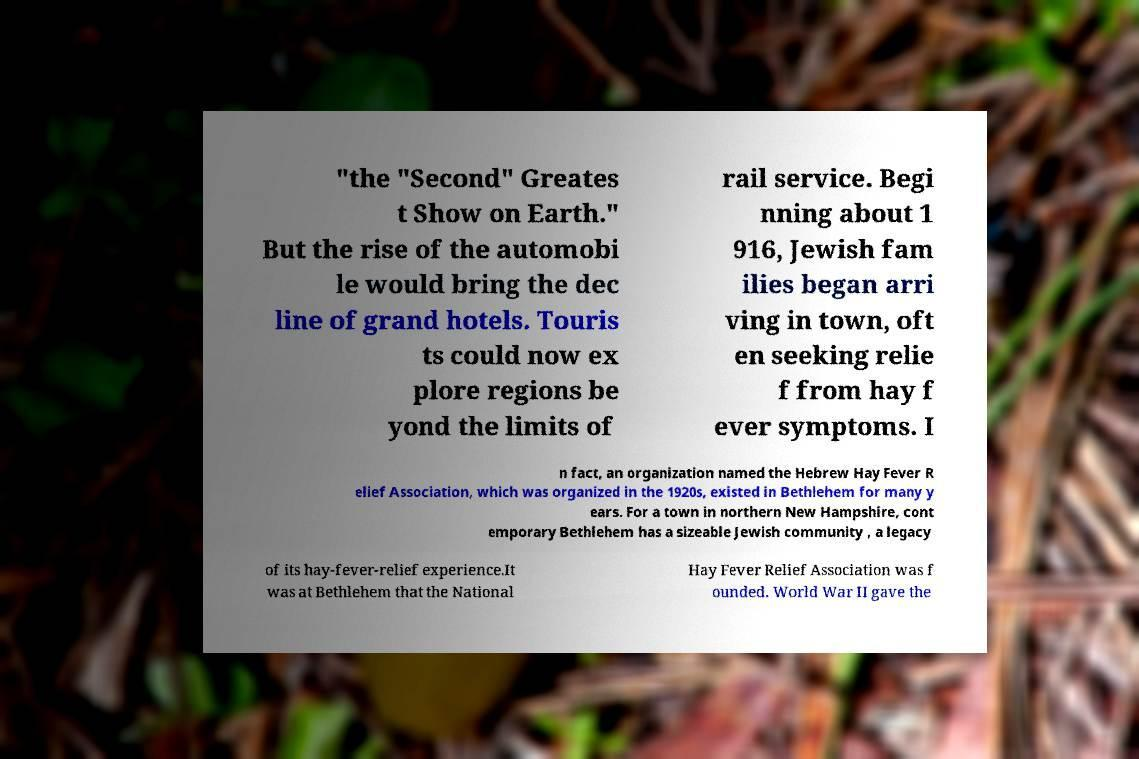Could you assist in decoding the text presented in this image and type it out clearly? "the "Second" Greates t Show on Earth." But the rise of the automobi le would bring the dec line of grand hotels. Touris ts could now ex plore regions be yond the limits of rail service. Begi nning about 1 916, Jewish fam ilies began arri ving in town, oft en seeking relie f from hay f ever symptoms. I n fact, an organization named the Hebrew Hay Fever R elief Association, which was organized in the 1920s, existed in Bethlehem for many y ears. For a town in northern New Hampshire, cont emporary Bethlehem has a sizeable Jewish community , a legacy of its hay-fever-relief experience.It was at Bethlehem that the National Hay Fever Relief Association was f ounded. World War II gave the 